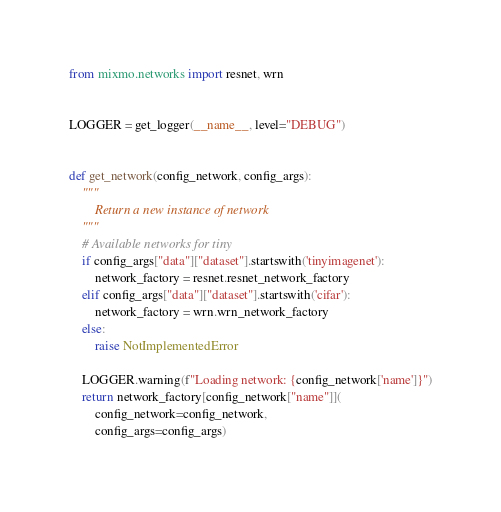Convert code to text. <code><loc_0><loc_0><loc_500><loc_500><_Python_>from mixmo.networks import resnet, wrn


LOGGER = get_logger(__name__, level="DEBUG")


def get_network(config_network, config_args):
    """
        Return a new instance of network
    """
    # Available networks for tiny
    if config_args["data"]["dataset"].startswith('tinyimagenet'):
        network_factory = resnet.resnet_network_factory
    elif config_args["data"]["dataset"].startswith('cifar'):
        network_factory = wrn.wrn_network_factory
    else:
        raise NotImplementedError

    LOGGER.warning(f"Loading network: {config_network['name']}")
    return network_factory[config_network["name"]](
        config_network=config_network,
        config_args=config_args)
</code> 